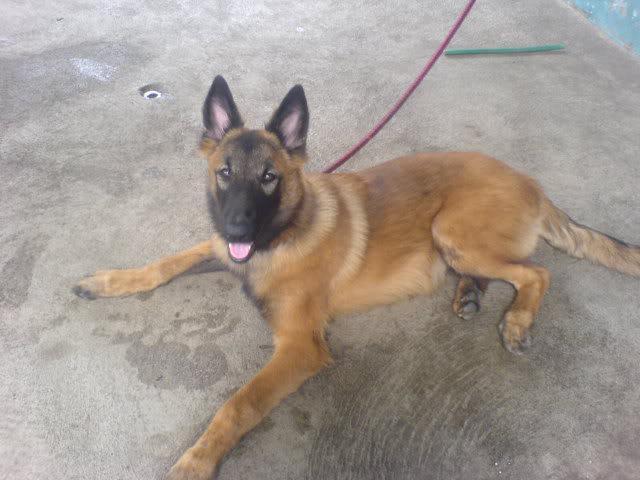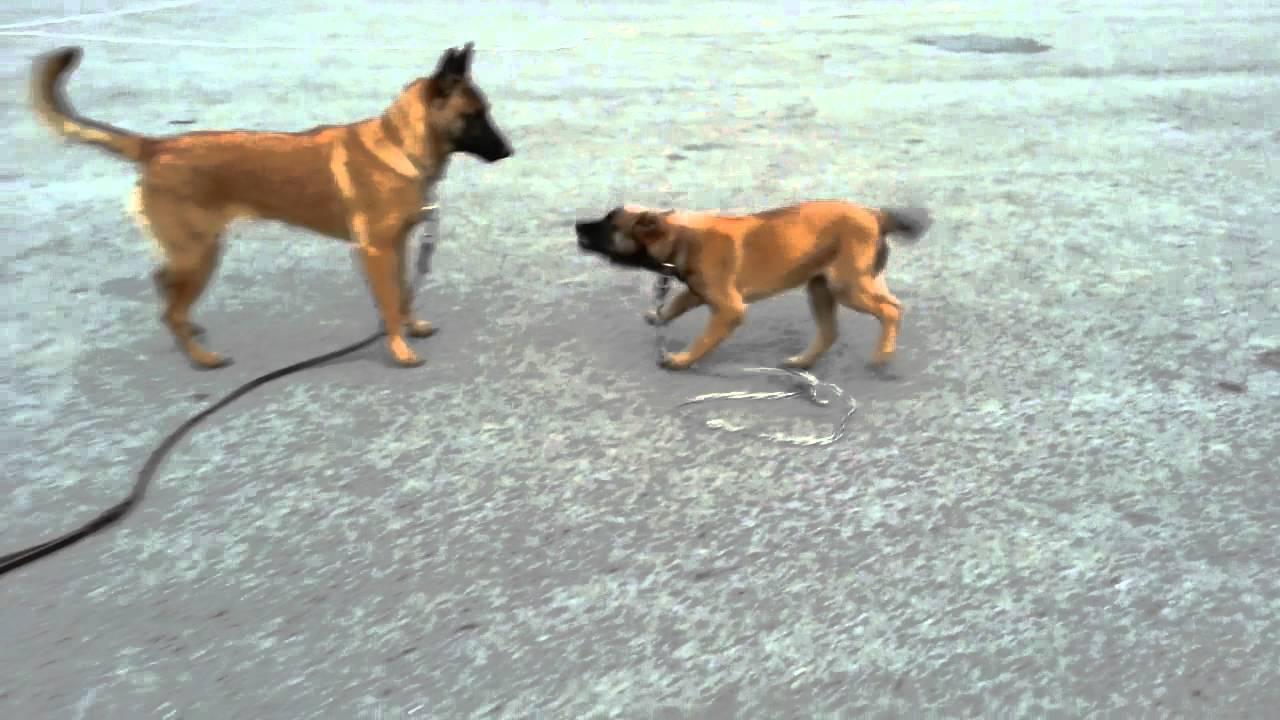The first image is the image on the left, the second image is the image on the right. Given the left and right images, does the statement "A german shepherd wearing a collar without a leash stands on the grass on all fours, with its tail nearly parallel to the ground." hold true? Answer yes or no. No. The first image is the image on the left, the second image is the image on the right. Assess this claim about the two images: "One dog is on a leash, while a second dog is not, but is wearing a collar and is standing on grass with its tongue out and tail outstretched.". Correct or not? Answer yes or no. No. 